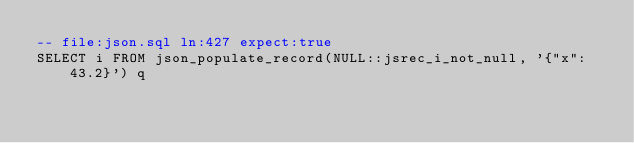<code> <loc_0><loc_0><loc_500><loc_500><_SQL_>-- file:json.sql ln:427 expect:true
SELECT i FROM json_populate_record(NULL::jsrec_i_not_null, '{"x": 43.2}') q
</code> 